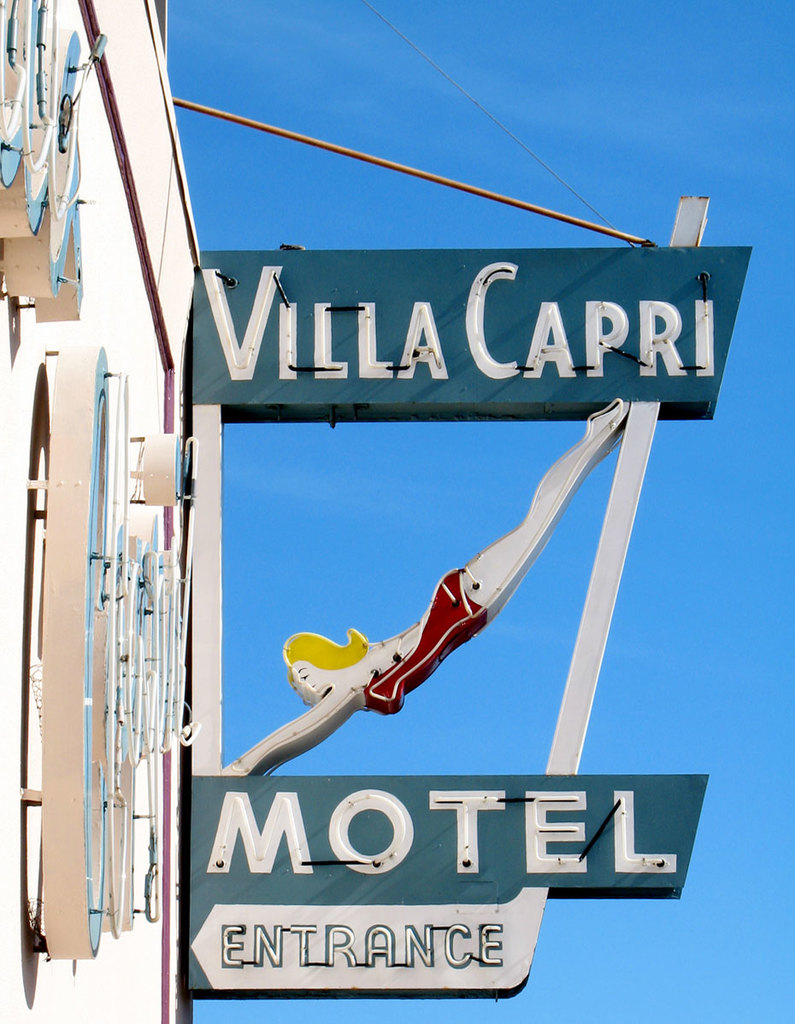What might be the cultural or symbolic significance of the mermaid figure on this motel sign? The inclusion of a mermaid figure on the Villa Capri Motel sign may carry several layers of cultural and symbolic significance. Traditionally, mermaids are mythical creatures associated with the allure and mystery of the sea. Their presence on a motel sign could evoke thoughts of escape, fantasy, and leisure, which aligns with the ideas of travel and retreat that motels cater to. Additionally, mermaids in popular culture are often depicted as enchanting and free-spirited, qualities that may entice travelers looking for a break from their routine. The mermaid could also be interpreted as a siren calling to weary travelers, inviting them to rest at this oasis amid their journey. 